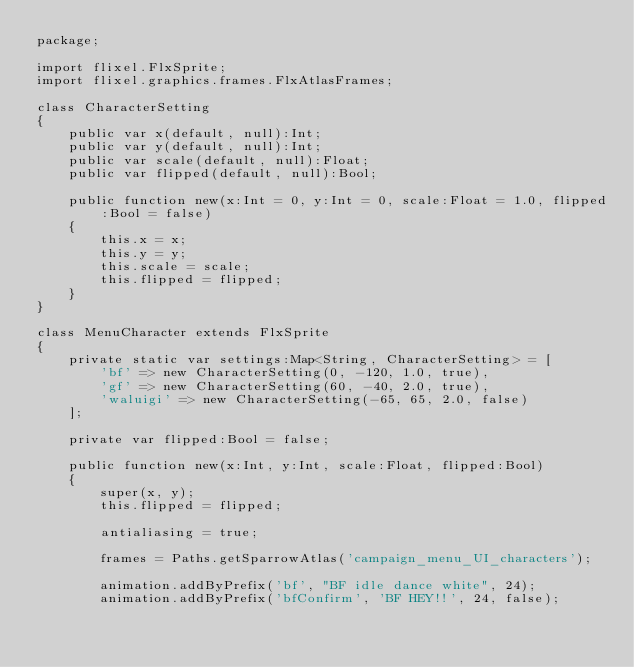Convert code to text. <code><loc_0><loc_0><loc_500><loc_500><_Haxe_>package;

import flixel.FlxSprite;
import flixel.graphics.frames.FlxAtlasFrames;

class CharacterSetting
{
	public var x(default, null):Int;
	public var y(default, null):Int;
	public var scale(default, null):Float;
	public var flipped(default, null):Bool;

	public function new(x:Int = 0, y:Int = 0, scale:Float = 1.0, flipped:Bool = false)
	{
		this.x = x;
		this.y = y;
		this.scale = scale;
		this.flipped = flipped;
	}
}

class MenuCharacter extends FlxSprite
{
	private static var settings:Map<String, CharacterSetting> = [
		'bf' => new CharacterSetting(0, -120, 1.0, true),
		'gf' => new CharacterSetting(60, -40, 2.0, true),
		'waluigi' => new CharacterSetting(-65, 65, 2.0, false)
	];

	private var flipped:Bool = false;

	public function new(x:Int, y:Int, scale:Float, flipped:Bool)
	{
		super(x, y);
		this.flipped = flipped;

		antialiasing = true;

		frames = Paths.getSparrowAtlas('campaign_menu_UI_characters');

		animation.addByPrefix('bf', "BF idle dance white", 24);
		animation.addByPrefix('bfConfirm', 'BF HEY!!', 24, false);</code> 